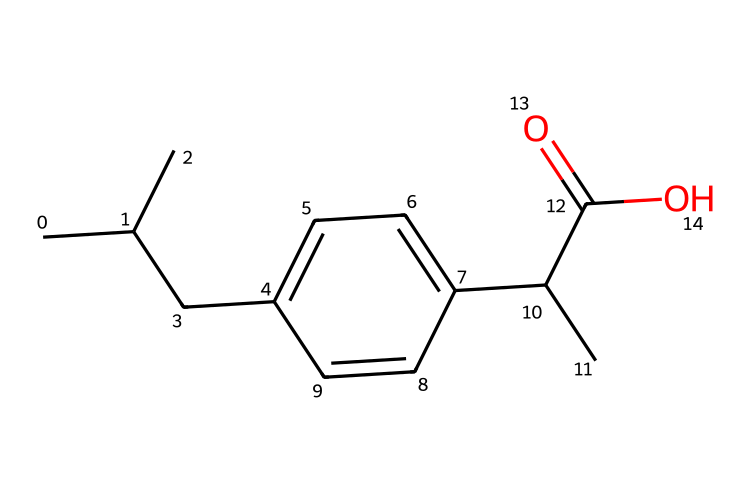What is the main functional group present in this chemical? The chemical has a carboxylic acid functional group, identifiable by the presence of the -COOH moiety in its structure.
Answer: carboxylic acid How many carbon atoms are in this molecule? By analyzing the SMILES representation, there are 12 carbon atoms present, which can be counted from the structure.
Answer: 12 What is the molecular weight of the compound represented by this SMILES? The molecular weight can be calculated by summing the atomic weights of all atoms (C, H, O) present based on the SMILES structure, resulting in a total approximately around 196.3 g/mol.
Answer: 196.3 Does this chemical contain any functional groups that would enhance its anti-inflammatory properties? Yes, the carboxylic acid functional group (–COOH) can enhance anti-inflammatory properties by forming hydrogen bonds and participating in biochemical interactions.
Answer: Yes What type of isomerism could this molecule exhibit? The structure has several stereocenters that allow for the possibility of geometric or optical isomerism due to different arrangements of atoms in the 3D space.
Answer: stereoisomerism How does the presence of the branched alkyl groups affect the solubility of this drug? The branched alkyl groups generally increase the hydrophobic character of the compound, which can affect solubility in biological systems; however, they may also enhance oral bioavailability due to increased membrane permeability.
Answer: Increases solubility 